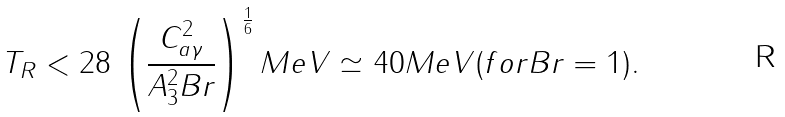Convert formula to latex. <formula><loc_0><loc_0><loc_500><loc_500>T _ { R } < 2 8 \, \left ( \frac { C _ { a \gamma } ^ { 2 } } { A _ { 3 } ^ { 2 } B r } \right ) ^ { \frac { 1 } { 6 } } M e V \simeq 4 0 M e V ( f o r B r = 1 ) .</formula> 